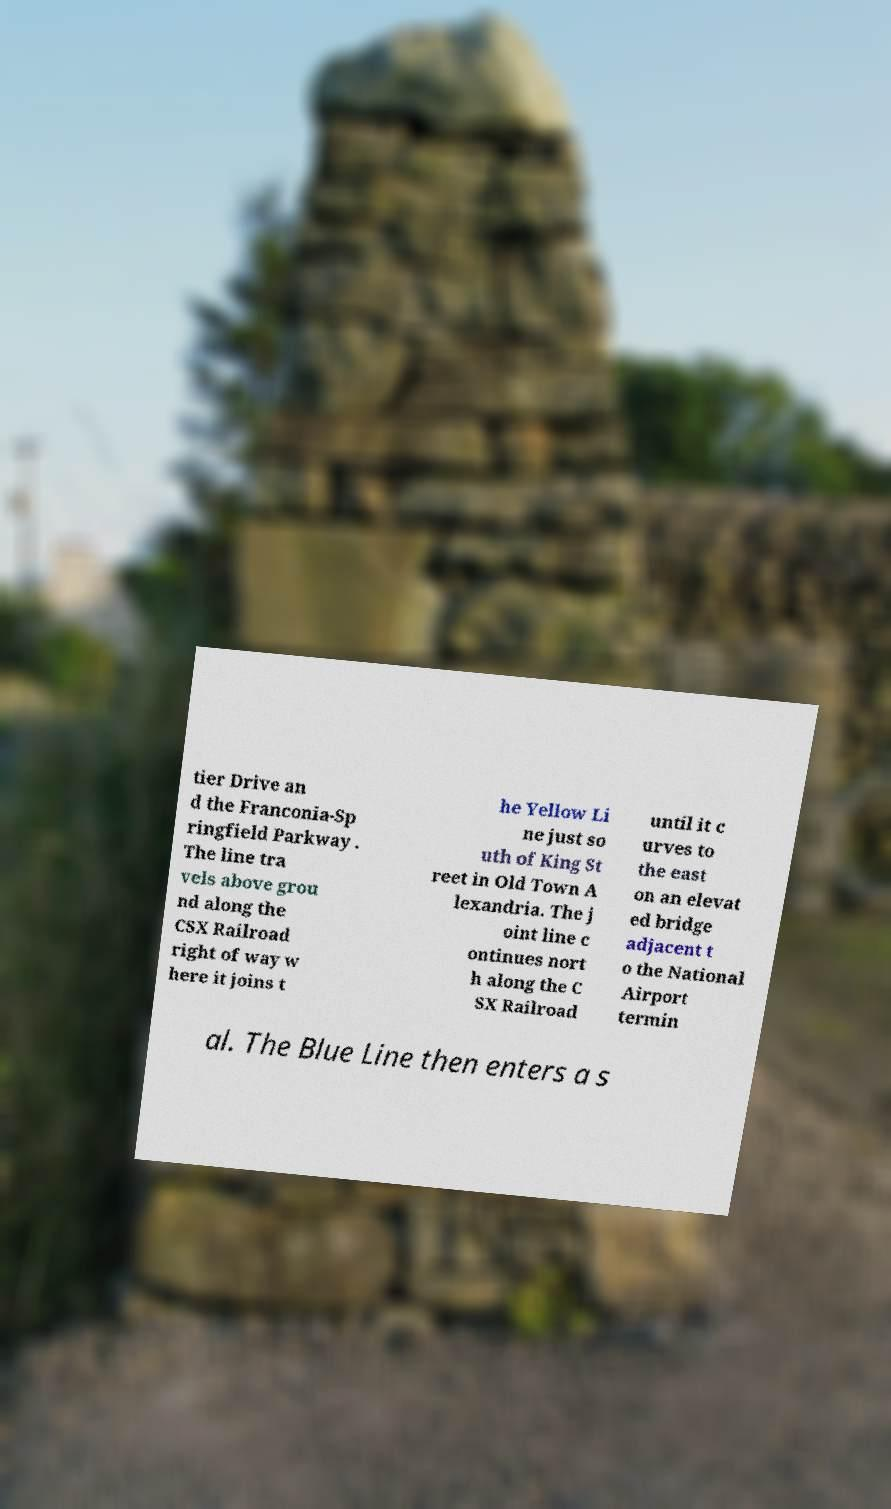I need the written content from this picture converted into text. Can you do that? tier Drive an d the Franconia-Sp ringfield Parkway . The line tra vels above grou nd along the CSX Railroad right of way w here it joins t he Yellow Li ne just so uth of King St reet in Old Town A lexandria. The j oint line c ontinues nort h along the C SX Railroad until it c urves to the east on an elevat ed bridge adjacent t o the National Airport termin al. The Blue Line then enters a s 